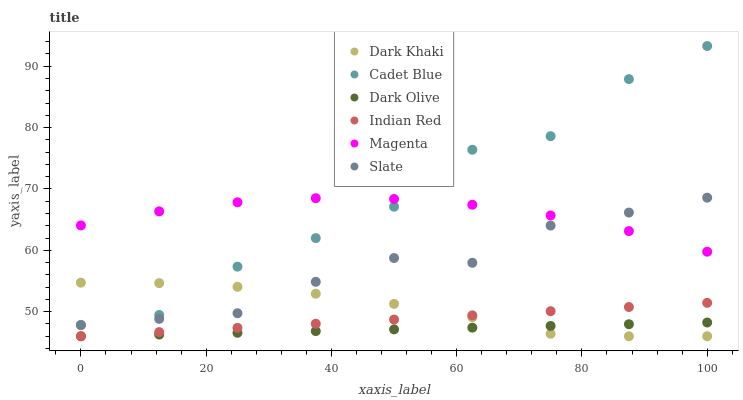Does Dark Olive have the minimum area under the curve?
Answer yes or no. Yes. Does Cadet Blue have the maximum area under the curve?
Answer yes or no. Yes. Does Slate have the minimum area under the curve?
Answer yes or no. No. Does Slate have the maximum area under the curve?
Answer yes or no. No. Is Dark Olive the smoothest?
Answer yes or no. Yes. Is Cadet Blue the roughest?
Answer yes or no. Yes. Is Slate the smoothest?
Answer yes or no. No. Is Slate the roughest?
Answer yes or no. No. Does Dark Olive have the lowest value?
Answer yes or no. Yes. Does Slate have the lowest value?
Answer yes or no. No. Does Cadet Blue have the highest value?
Answer yes or no. Yes. Does Slate have the highest value?
Answer yes or no. No. Is Dark Olive less than Magenta?
Answer yes or no. Yes. Is Magenta greater than Indian Red?
Answer yes or no. Yes. Does Dark Khaki intersect Indian Red?
Answer yes or no. Yes. Is Dark Khaki less than Indian Red?
Answer yes or no. No. Is Dark Khaki greater than Indian Red?
Answer yes or no. No. Does Dark Olive intersect Magenta?
Answer yes or no. No. 